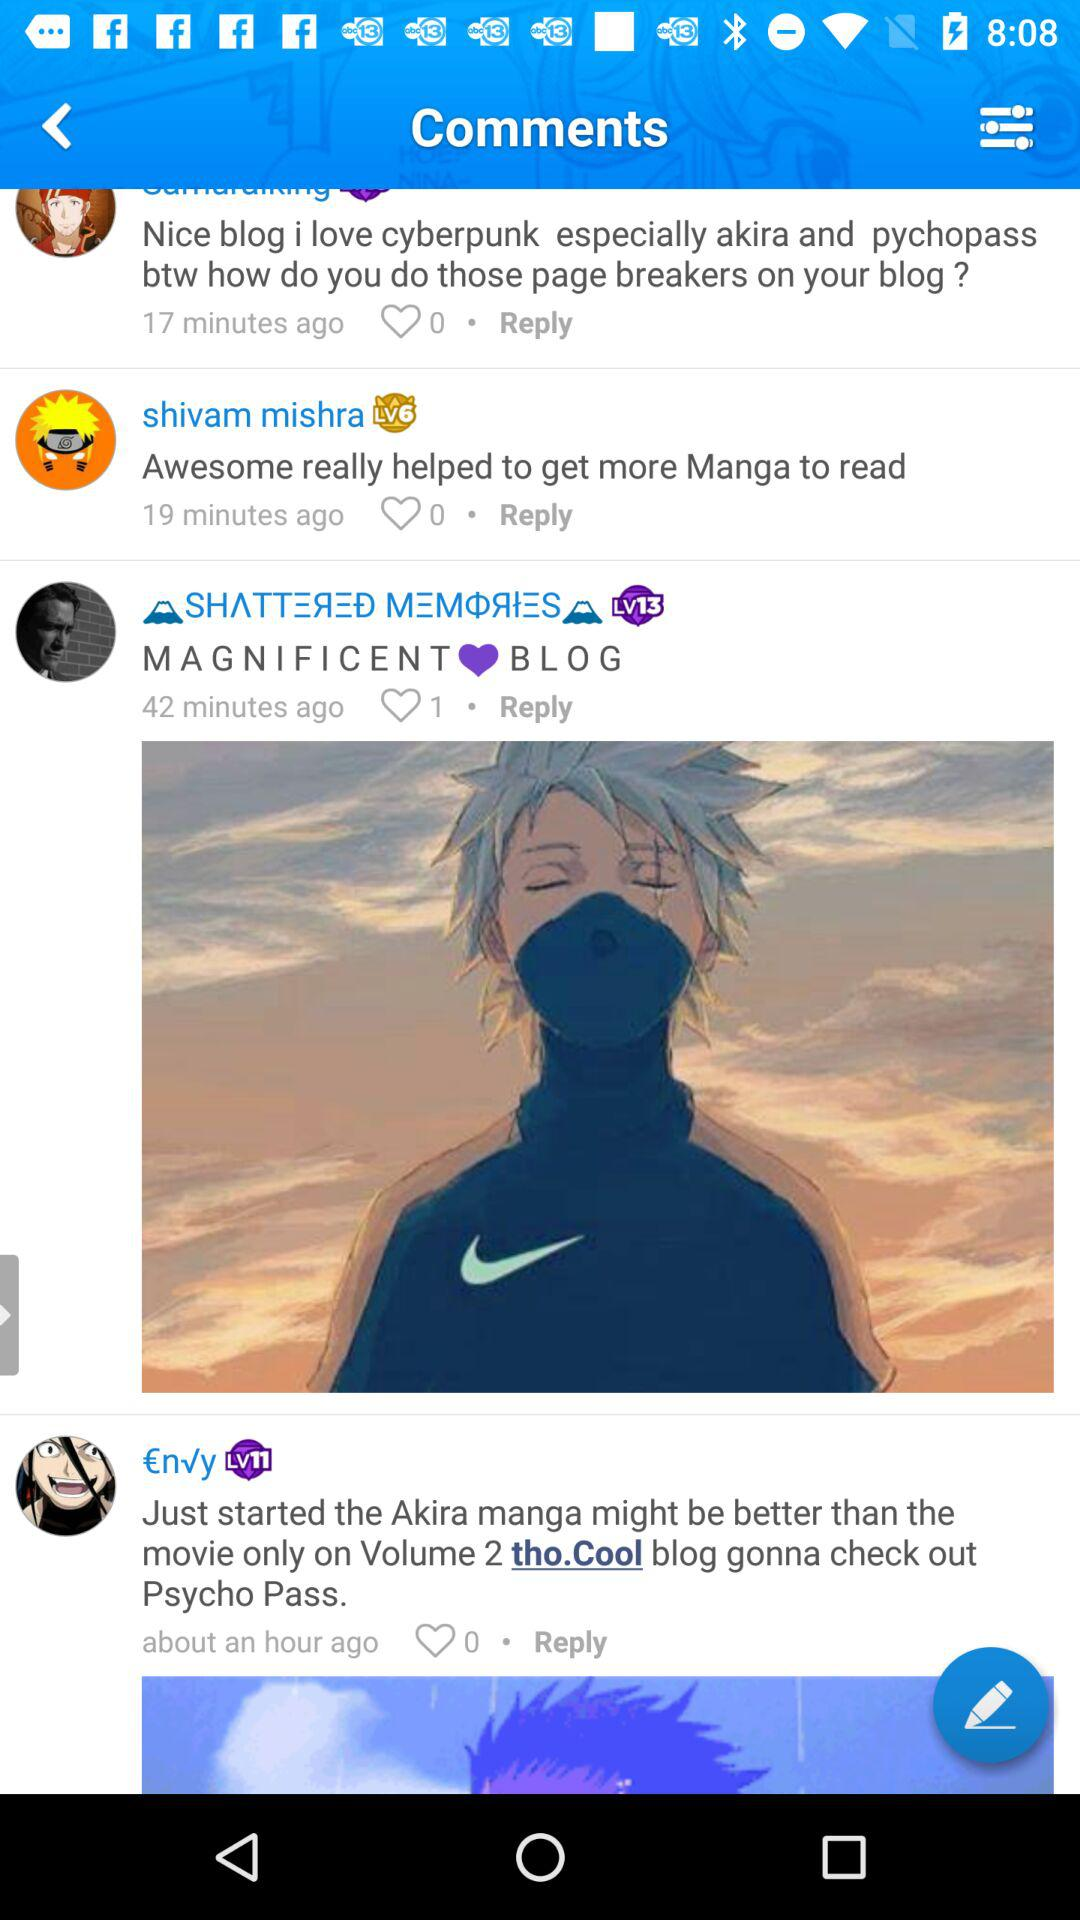At what time did Shivam Mishra comment? Shivam Mishra commented 19 minutes ago. 